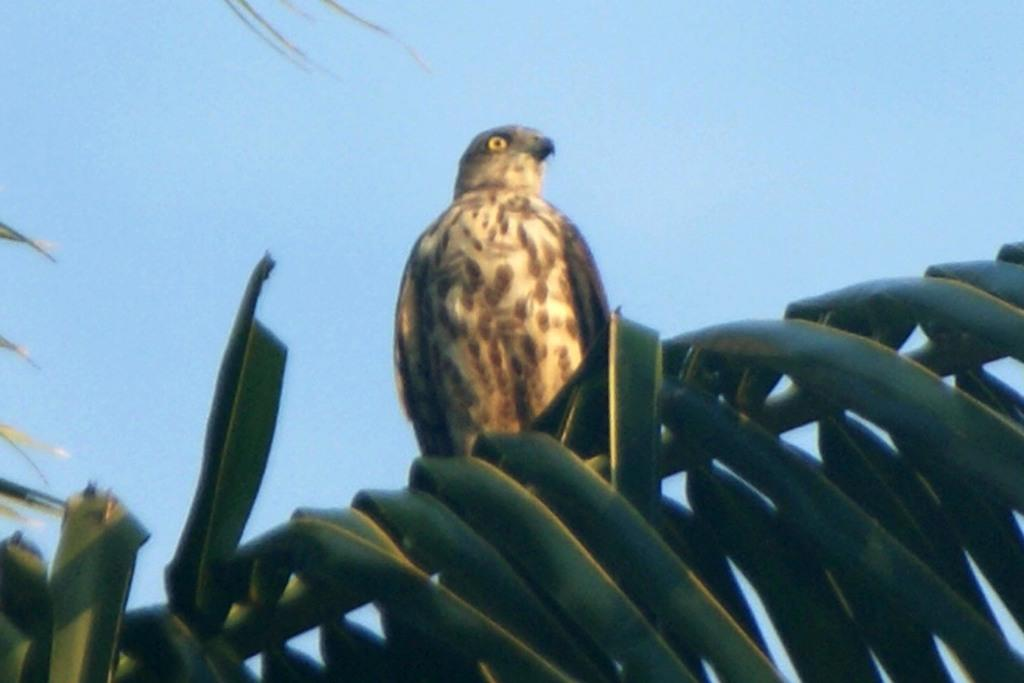What is on the leaves in the image? There is a bird on the leaves in the image. What color is the sky in the image? The sky is blue in color. Can you see a giraffe driving a car in the image? No, there is no giraffe or car present in the image. What type of fruit is hanging from the leaves in the image? There is no fruit visible in the image; only a bird is present on the leaves. 